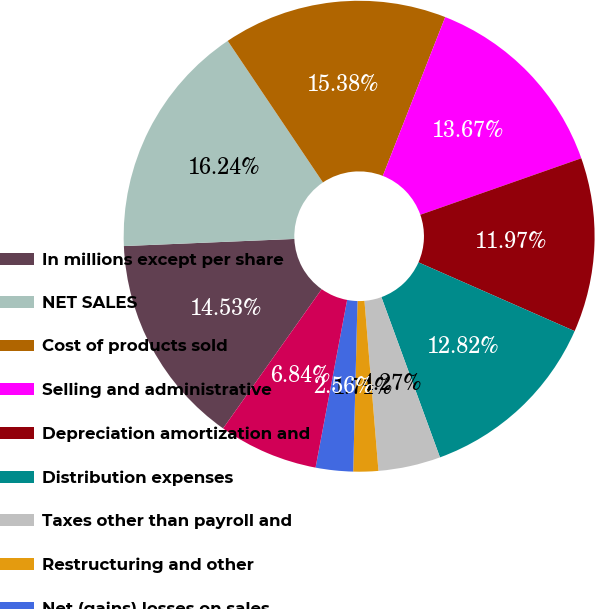Convert chart to OTSL. <chart><loc_0><loc_0><loc_500><loc_500><pie_chart><fcel>In millions except per share<fcel>NET SALES<fcel>Cost of products sold<fcel>Selling and administrative<fcel>Depreciation amortization and<fcel>Distribution expenses<fcel>Taxes other than payroll and<fcel>Restructuring and other<fcel>Net (gains) losses on sales<fcel>Interest expense net<nl><fcel>14.53%<fcel>16.24%<fcel>15.38%<fcel>13.67%<fcel>11.97%<fcel>12.82%<fcel>4.27%<fcel>1.71%<fcel>2.56%<fcel>6.84%<nl></chart> 